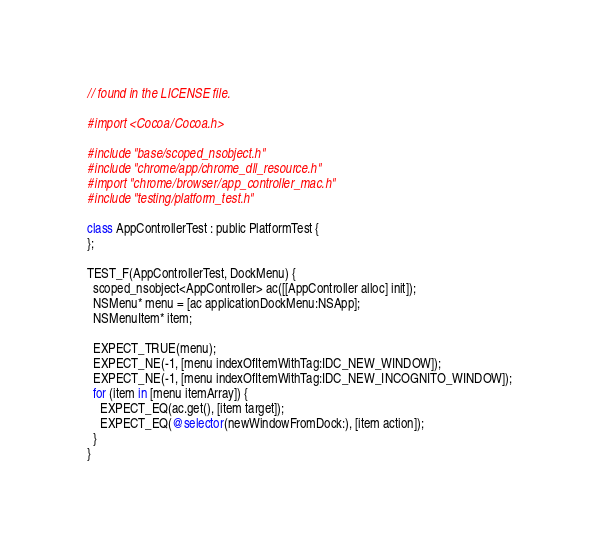<code> <loc_0><loc_0><loc_500><loc_500><_ObjectiveC_>// found in the LICENSE file.

#import <Cocoa/Cocoa.h>

#include "base/scoped_nsobject.h"
#include "chrome/app/chrome_dll_resource.h"
#import "chrome/browser/app_controller_mac.h"
#include "testing/platform_test.h"

class AppControllerTest : public PlatformTest {
};

TEST_F(AppControllerTest, DockMenu) {
  scoped_nsobject<AppController> ac([[AppController alloc] init]);
  NSMenu* menu = [ac applicationDockMenu:NSApp];
  NSMenuItem* item;

  EXPECT_TRUE(menu);
  EXPECT_NE(-1, [menu indexOfItemWithTag:IDC_NEW_WINDOW]);
  EXPECT_NE(-1, [menu indexOfItemWithTag:IDC_NEW_INCOGNITO_WINDOW]);
  for (item in [menu itemArray]) {
    EXPECT_EQ(ac.get(), [item target]);
    EXPECT_EQ(@selector(newWindowFromDock:), [item action]);
  }
}
</code> 